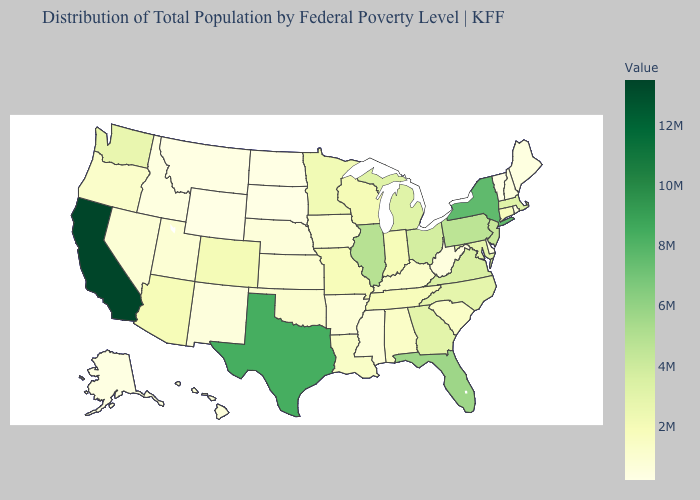Does Vermont have the lowest value in the USA?
Answer briefly. Yes. Does Colorado have the highest value in the West?
Answer briefly. No. Does New York have the highest value in the Northeast?
Be succinct. Yes. Is the legend a continuous bar?
Keep it brief. Yes. Is the legend a continuous bar?
Short answer required. Yes. 